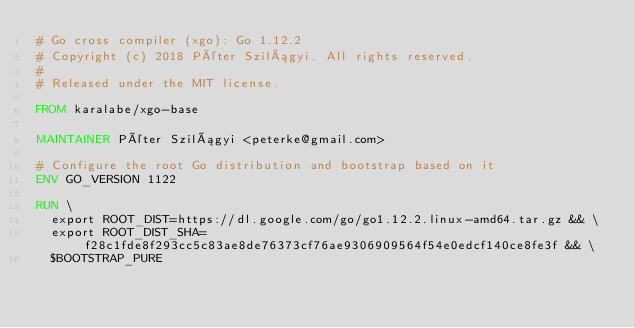Convert code to text. <code><loc_0><loc_0><loc_500><loc_500><_Dockerfile_># Go cross compiler (xgo): Go 1.12.2
# Copyright (c) 2018 Péter Szilágyi. All rights reserved.
#
# Released under the MIT license.

FROM karalabe/xgo-base

MAINTAINER Péter Szilágyi <peterke@gmail.com>

# Configure the root Go distribution and bootstrap based on it
ENV GO_VERSION 1122

RUN \
  export ROOT_DIST=https://dl.google.com/go/go1.12.2.linux-amd64.tar.gz && \
  export ROOT_DIST_SHA=f28c1fde8f293cc5c83ae8de76373cf76ae9306909564f54e0edcf140ce8fe3f && \
  $BOOTSTRAP_PURE
</code> 